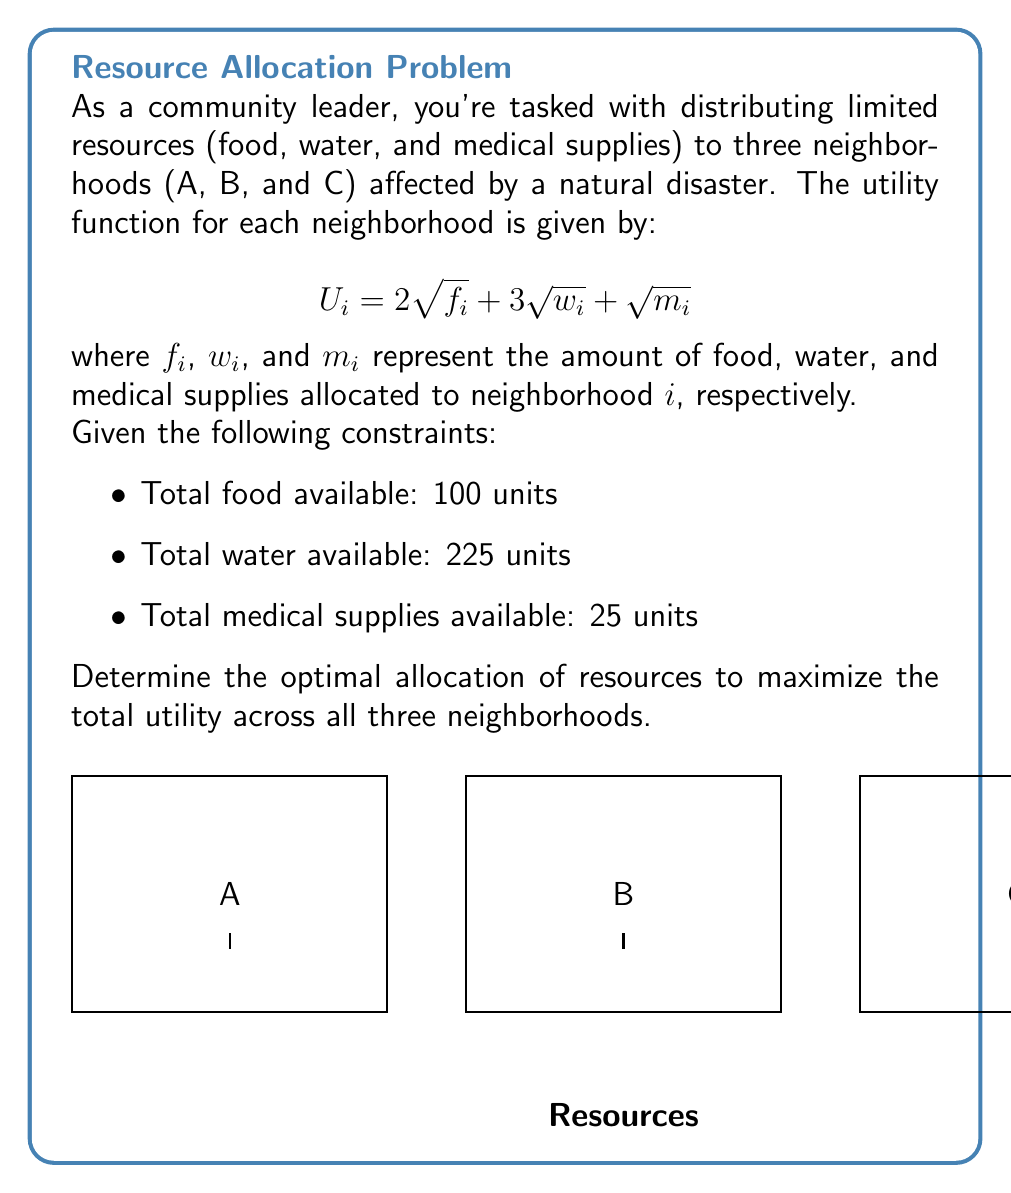What is the answer to this math problem? To solve this optimization problem, we'll use the method of Lagrange multipliers:

1) Define the objective function:
   $$U_{total} = U_A + U_B + U_C = \sum_{i=A,B,C} (2\sqrt{f_i} + 3\sqrt{w_i} + \sqrt{m_i})$$

2) Define the constraint functions:
   $$g_1: f_A + f_B + f_C = 100$$
   $$g_2: w_A + w_B + w_C = 225$$
   $$g_3: m_A + m_B + m_C = 25$$

3) Form the Lagrangian:
   $$L = U_{total} - \lambda_1(f_A + f_B + f_C - 100) - \lambda_2(w_A + w_B + w_C - 225) - \lambda_3(m_A + m_B + m_C - 25)$$

4) Take partial derivatives and set them equal to zero:
   $$\frac{\partial L}{\partial f_i} = \frac{1}{\sqrt{f_i}} - \lambda_1 = 0$$
   $$\frac{\partial L}{\partial w_i} = \frac{3}{2\sqrt{w_i}} - \lambda_2 = 0$$
   $$\frac{\partial L}{\partial m_i} = \frac{1}{2\sqrt{m_i}} - \lambda_3 = 0$$

5) From these equations, we can deduce that $f_A = f_B = f_C$, $w_A = w_B = w_C$, and $m_A = m_B = m_C$ due to symmetry.

6) Solving the equations:
   $$f_A = f_B = f_C = 100/3 \approx 33.33$$
   $$w_A = w_B = w_C = 225/3 = 75$$
   $$m_A = m_B = m_C = 25/3 \approx 8.33$$

Therefore, the optimal allocation is to distribute resources equally among the three neighborhoods.
Answer: Equal distribution: $(\frac{100}{3}, \frac{225}{3}, \frac{25}{3})$ units of (food, water, medical supplies) to each neighborhood. 